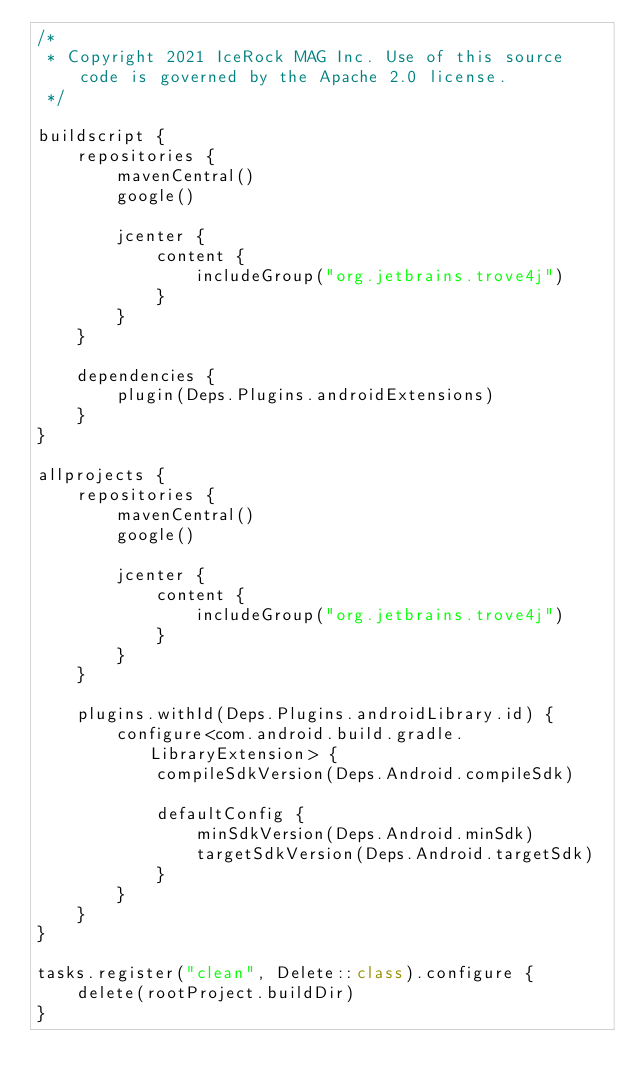<code> <loc_0><loc_0><loc_500><loc_500><_Kotlin_>/*
 * Copyright 2021 IceRock MAG Inc. Use of this source code is governed by the Apache 2.0 license.
 */

buildscript {
    repositories {
        mavenCentral()
        google()

        jcenter {
            content {
                includeGroup("org.jetbrains.trove4j")
            }
        }
    }

    dependencies {
        plugin(Deps.Plugins.androidExtensions)
    }
}

allprojects {
    repositories {
        mavenCentral()
        google()

        jcenter {
            content {
                includeGroup("org.jetbrains.trove4j")
            }
        }
    }

    plugins.withId(Deps.Plugins.androidLibrary.id) {
        configure<com.android.build.gradle.LibraryExtension> {
            compileSdkVersion(Deps.Android.compileSdk)

            defaultConfig {
                minSdkVersion(Deps.Android.minSdk)
                targetSdkVersion(Deps.Android.targetSdk)
            }
        }
    }
}

tasks.register("clean", Delete::class).configure {
    delete(rootProject.buildDir)
}
</code> 